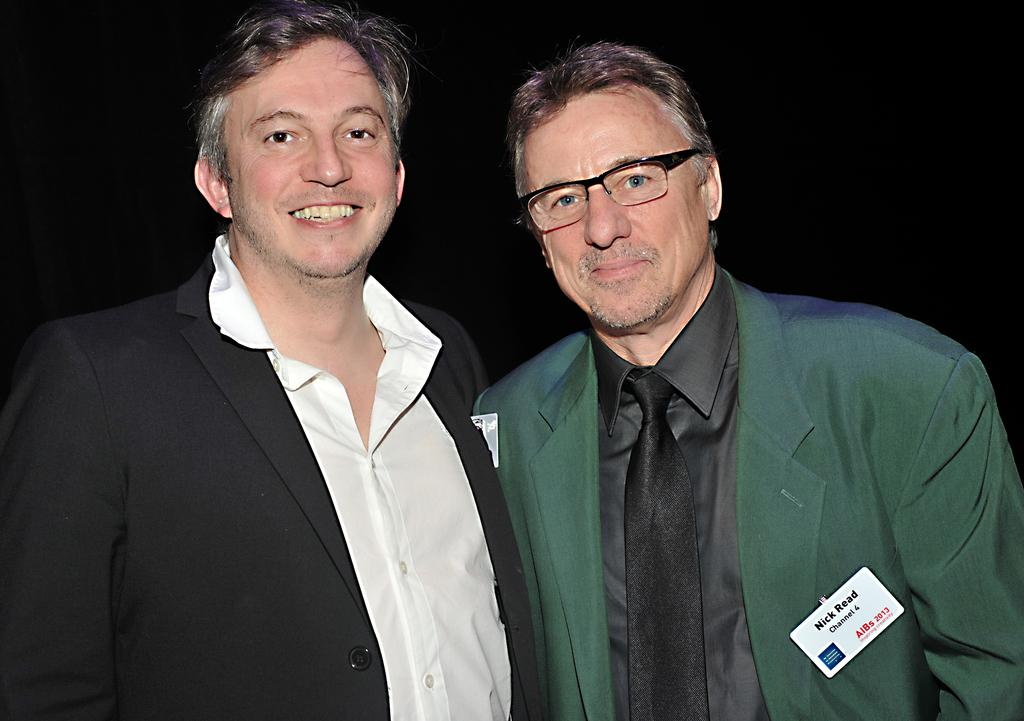How many people are in the image? There are two persons in the image. What are the positions of the persons in the image? Both persons are standing. What are the persons wearing in the image? Both persons are wearing coats. Can you describe any additional accessories worn by one of the persons? One of the persons is wearing spectacles. What type of jam is being spread on the mice in the image? There are no mice or jam present in the image. How many marks can be seen on the person wearing spectacles? There is no mention of marks on the person wearing spectacles in the image. 